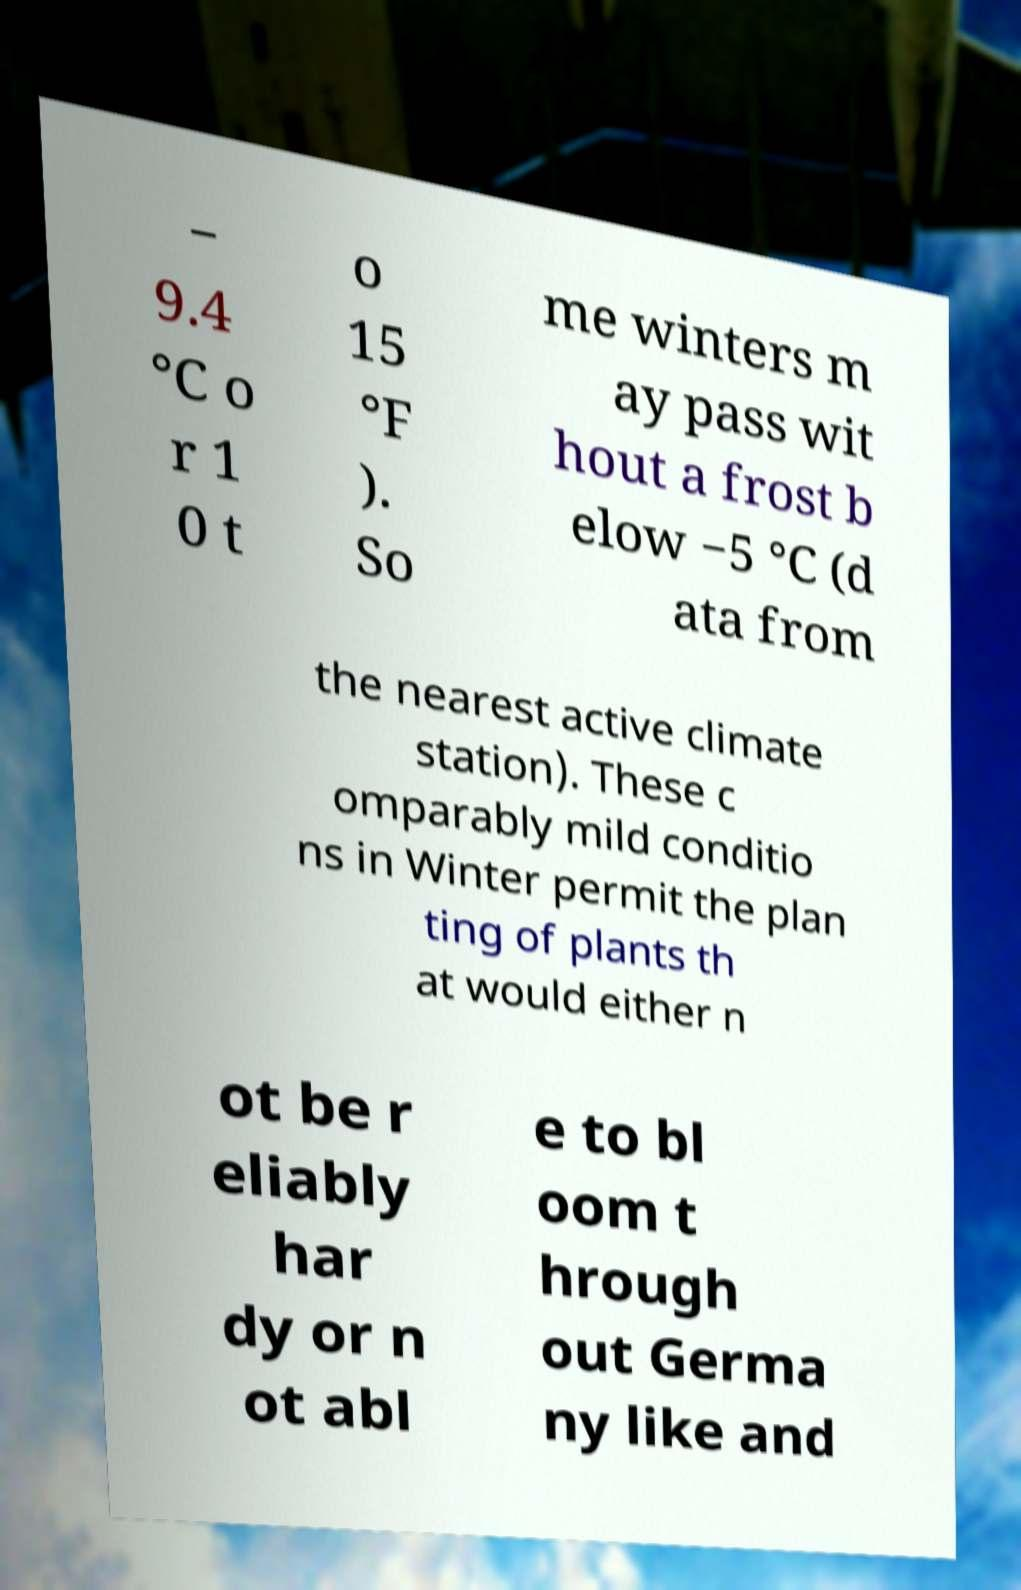Can you read and provide the text displayed in the image?This photo seems to have some interesting text. Can you extract and type it out for me? − 9.4 °C o r 1 0 t o 15 °F ). So me winters m ay pass wit hout a frost b elow −5 °C (d ata from the nearest active climate station). These c omparably mild conditio ns in Winter permit the plan ting of plants th at would either n ot be r eliably har dy or n ot abl e to bl oom t hrough out Germa ny like and 